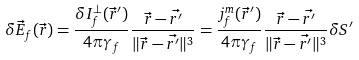<formula> <loc_0><loc_0><loc_500><loc_500>\delta \vec { E } _ { f } ( \vec { r } ) = \frac { \delta I _ { f } ^ { \perp } ( \vec { r } ^ { \prime } ) } { 4 \pi \gamma _ { f } } \frac { \vec { r } - \vec { r ^ { \prime } } } { \| \vec { r } - \vec { r ^ { \prime } } \| ^ { 3 } } = \frac { j _ { f } ^ { m } ( \vec { r } ^ { \prime } ) } { 4 \pi \gamma _ { f } } \frac { \vec { r } - \vec { r ^ { \prime } } } { \| \vec { r } - \vec { r ^ { \prime } } \| ^ { 3 } } \delta S ^ { \prime }</formula> 